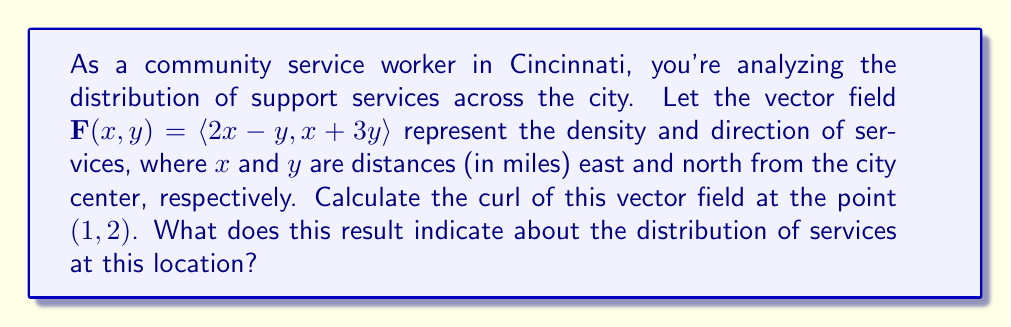Could you help me with this problem? To solve this problem, we'll follow these steps:

1) The curl of a two-dimensional vector field $\mathbf{F}(x,y) = \langle P(x,y), Q(x,y) \rangle$ is given by:

   $$\text{curl } \mathbf{F} = \frac{\partial Q}{\partial x} - \frac{\partial P}{\partial y}$$

2) In our case, $P(x,y) = 2x-y$ and $Q(x,y) = x+3y$

3) Let's calculate the partial derivatives:
   
   $\frac{\partial Q}{\partial x} = \frac{\partial}{\partial x}(x+3y) = 1$
   
   $\frac{\partial P}{\partial y} = \frac{\partial}{\partial y}(2x-y) = -1$

4) Now we can calculate the curl:

   $$\text{curl } \mathbf{F} = \frac{\partial Q}{\partial x} - \frac{\partial P}{\partial y} = 1 - (-1) = 2$$

5) This result is constant for all points in the field, including (1, 2).

The curl of a vector field measures the tendency of the field to rotate around a point. A positive curl indicates counterclockwise rotation, while a negative curl indicates clockwise rotation. The magnitude of the curl represents the strength of this rotational tendency.

In the context of community support services, a positive curl of 2 at the point (1, 2) suggests that there's a tendency for services to be distributed in a counterclockwise pattern around this location. This could indicate a slight imbalance in service distribution, with potentially more services available in some directions than others around this point.
Answer: The curl of the vector field at the point (1, 2) is 2. This indicates a counterclockwise rotational tendency in the distribution of community support services around this location, suggesting a slight imbalance in service availability in different directions from this point. 